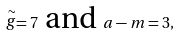Convert formula to latex. <formula><loc_0><loc_0><loc_500><loc_500>\stackrel { \sim } { g } = 7 \text { and } a - m = 3 ,</formula> 